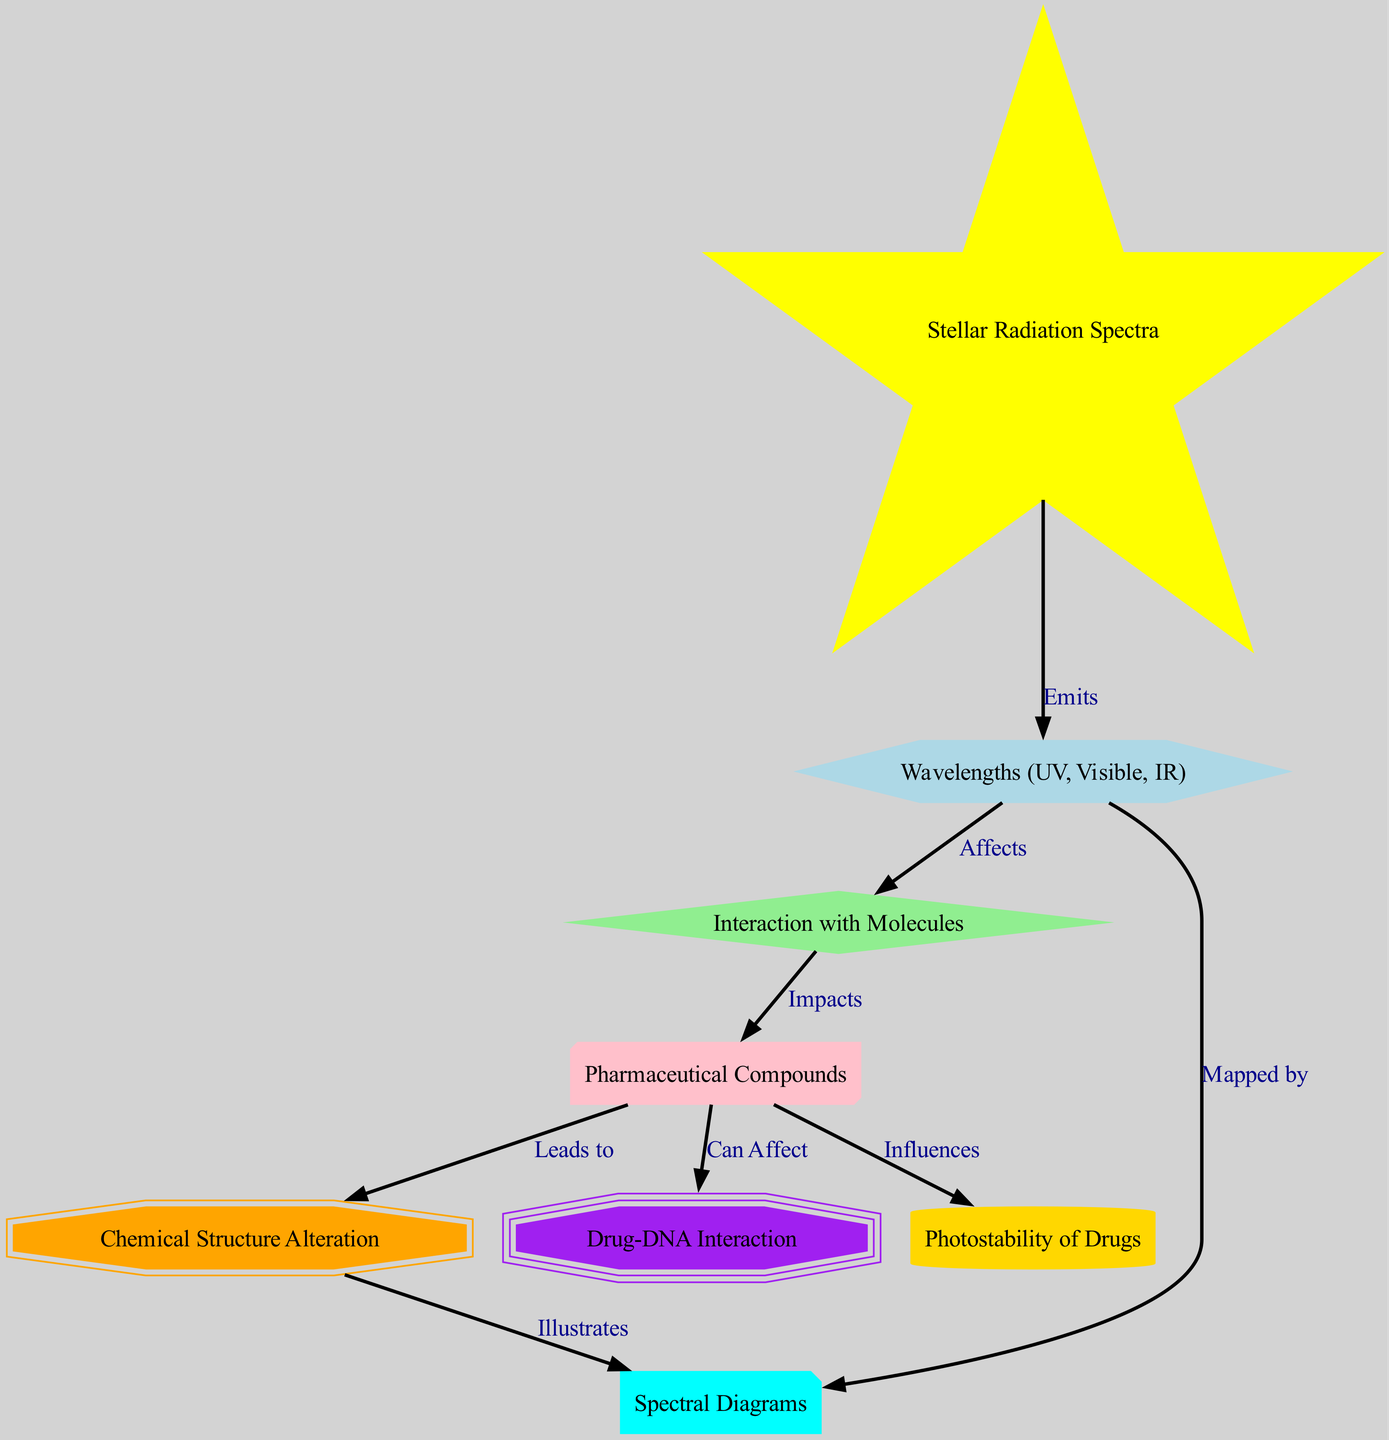What are the primary wavelengths mentioned in the diagram? The diagram indicates wavelengths as "UV", "Visible", and "IR". These are clearly labeled under the "Wavelengths" node.
Answer: UV, Visible, IR How many nodes are present in the diagram? Counting the nodes listed, there are 8 distinct nodes including "StarSpectra", "Wavelengths", "MolecularInteraction", "PharmaceuticalCompounds", "ChemicalChange", "SpectralDiagram", "DNAInteraction", and "Photostability".
Answer: 8 What relationship does "Wavelengths" have with "MolecularInteraction"? The diagram shows that "Wavelengths" "Affects" "MolecularInteraction", as illustrated by the directed edge connecting these two nodes.
Answer: Affects What node represents the effect of stellar radiation on drug structures? The "ChemicalChange" node illustrates how pharmaceutical compounds alter due to their interaction with stellar radiation.
Answer: ChemicalChange What influence do pharmaceutical compounds have on DNA interaction according to the diagram? The diagram specifies that pharmaceutical compounds "Can Affect" DNA interaction, indicating a potential impact on genetic material.
Answer: Can Affect How does "Wavelengths" relate to "SpectralDiagram"? The edge between "Wavelengths" and "SpectralDiagram" shows that wavelengths are "Mapped by" the spectral diagram, representing their distribution visually.
Answer: Mapped by What aspect of pharmaceutical compounds does "Photostability" involve? The relationship indicates that pharmaceutical compounds "Influences" the photostability of drugs, showing their role in maintaining stability under light exposure.
Answer: Influences What is showcased through the connection between "ChemicalChange" and "SpectralDiagram"? The diagram illustrates that "ChemicalChange" "Illustrates" in the spectral diagram, meaning that changes in chemical structure can be depicted visually.
Answer: Illustrates Which node is associated with how stellar spectra affect pharmaceutical compounds? The "MolecularInteraction" node directly represents how stellar spectra, through wavelengths, impact the interaction with pharmaceutical compounds.
Answer: MolecularInteraction 